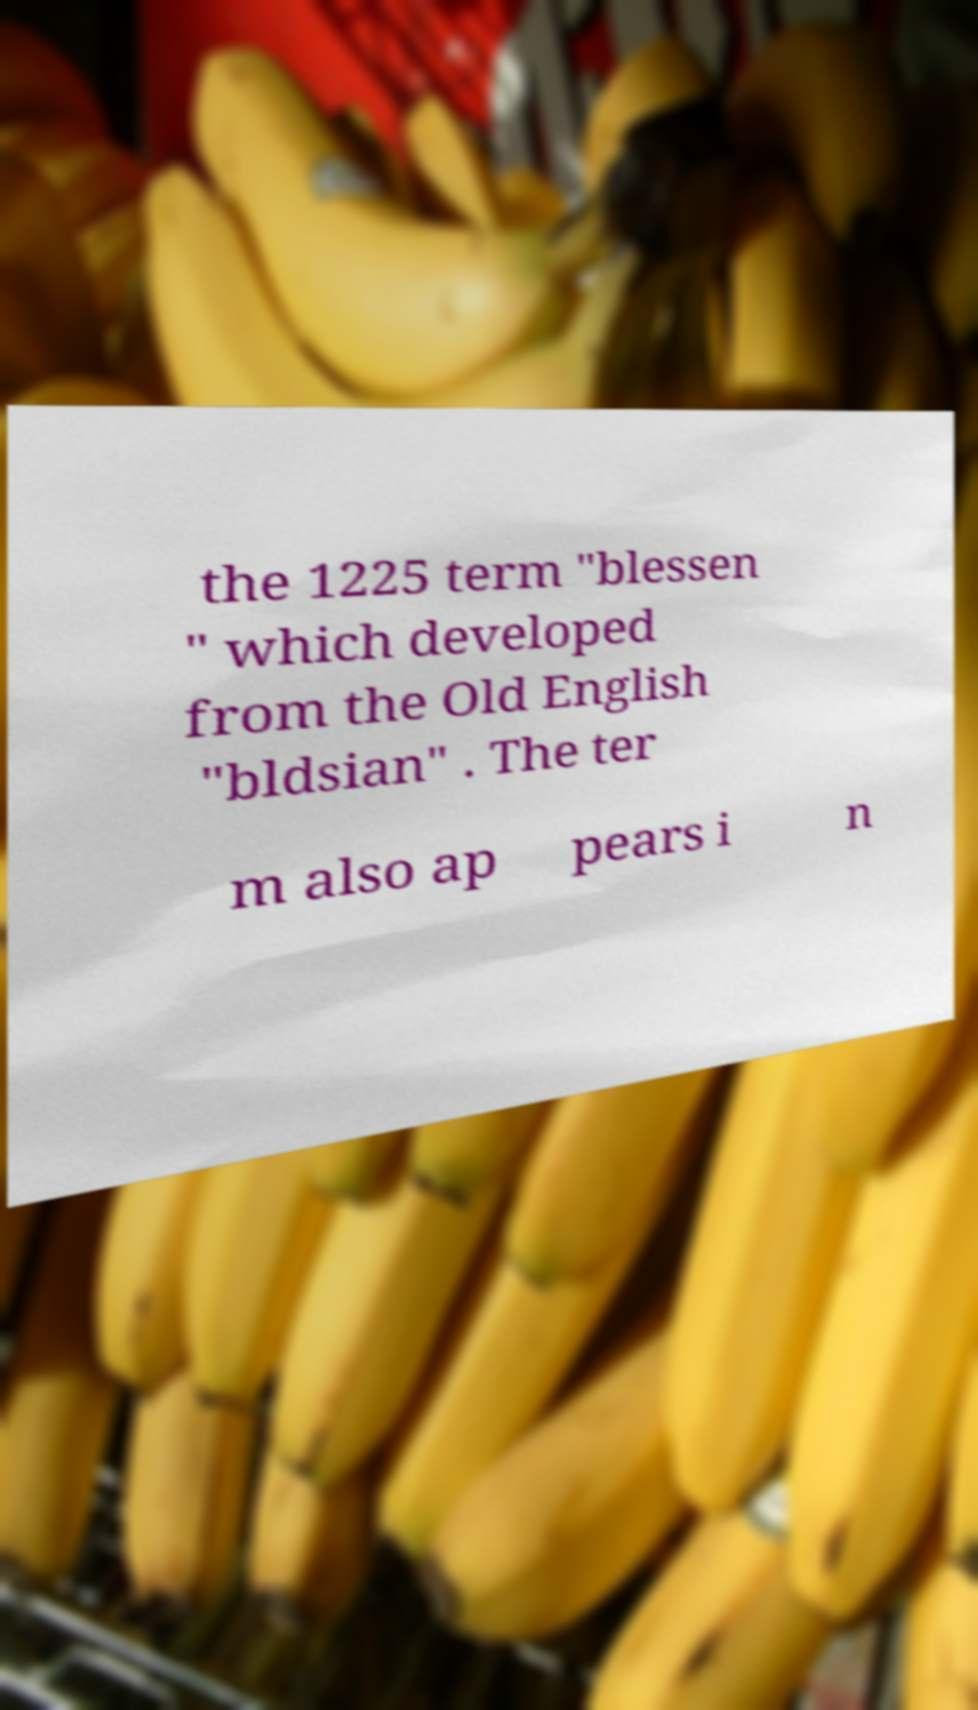Please read and relay the text visible in this image. What does it say? the 1225 term "blessen " which developed from the Old English "bldsian" . The ter m also ap pears i n 